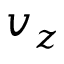<formula> <loc_0><loc_0><loc_500><loc_500>v _ { z }</formula> 